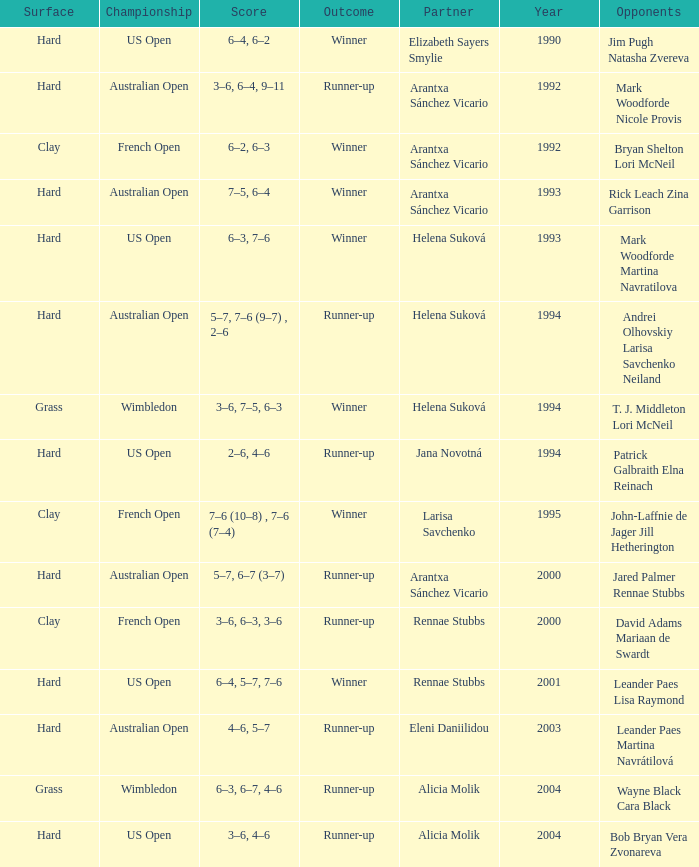Which Score has smaller than 1994, and a Partner of elizabeth sayers smylie? 6–4, 6–2. 